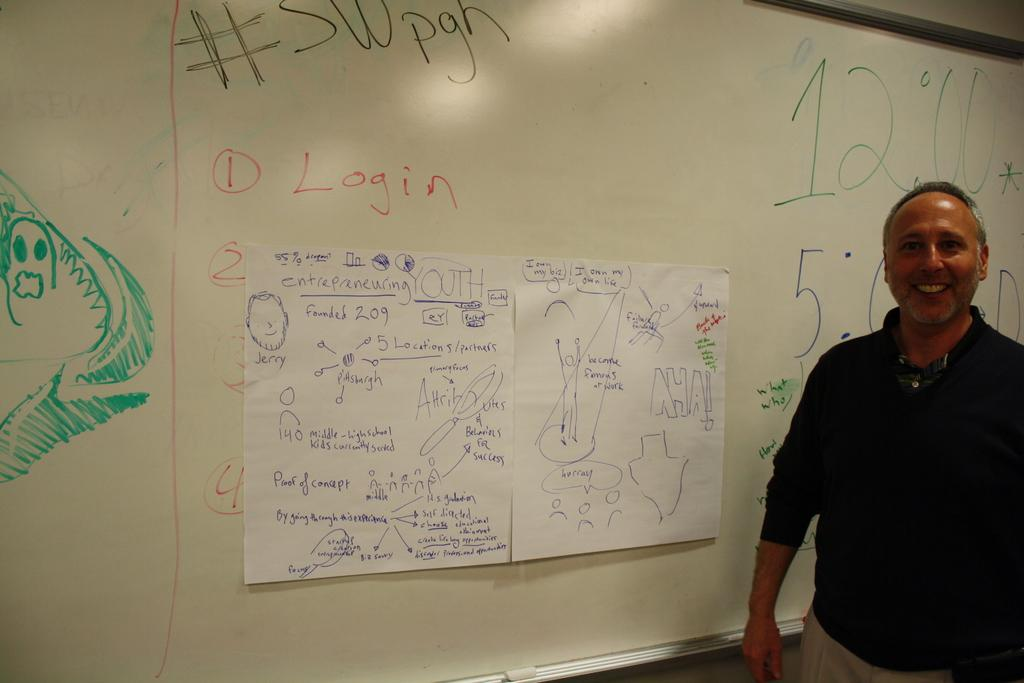Provide a one-sentence caption for the provided image. A man is in front of a whiteboard 2 pages taped to the board under the word Login. 